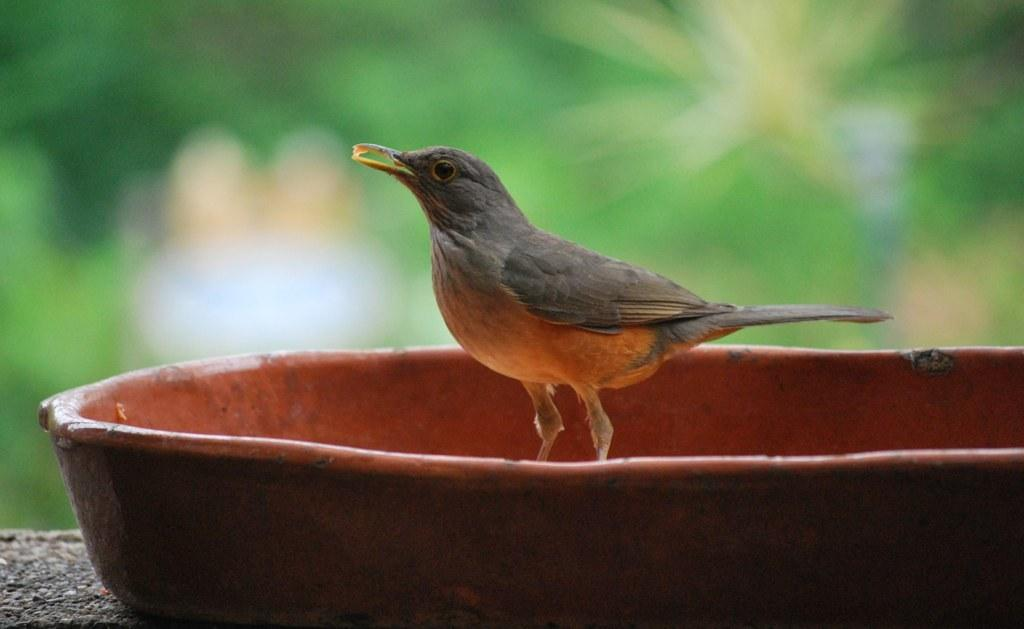What type of animal can be seen in the image? There is a bird in the image. What is the bird standing on? The bird is standing on an object. Can you describe the color of the object? The object is red in color. How would you describe the background of the image? The background of the image is blurry. What word is written on the seashore in the image? There is no seashore or word present in the image. 